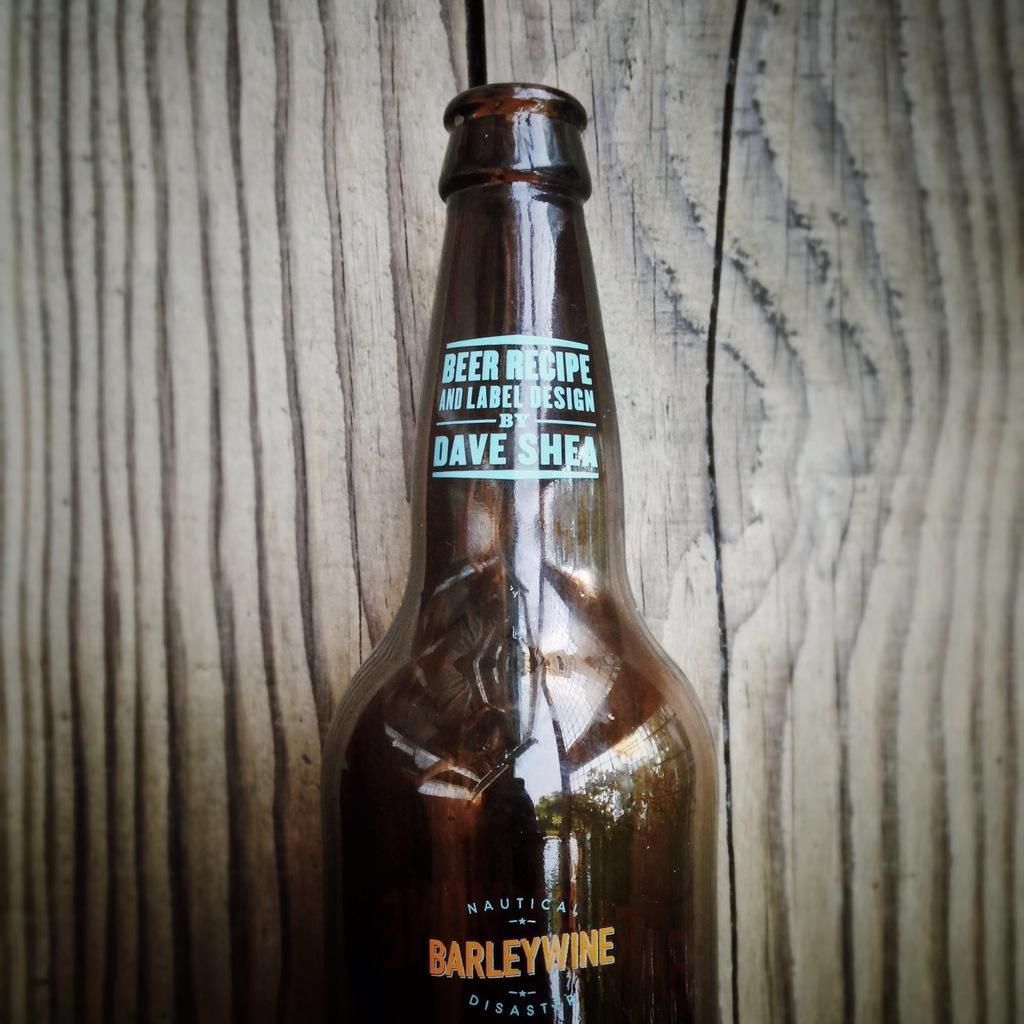<image>
Write a terse but informative summary of the picture. A bottle is labeled Barleywine and has the name Dave Shea towards the top. 